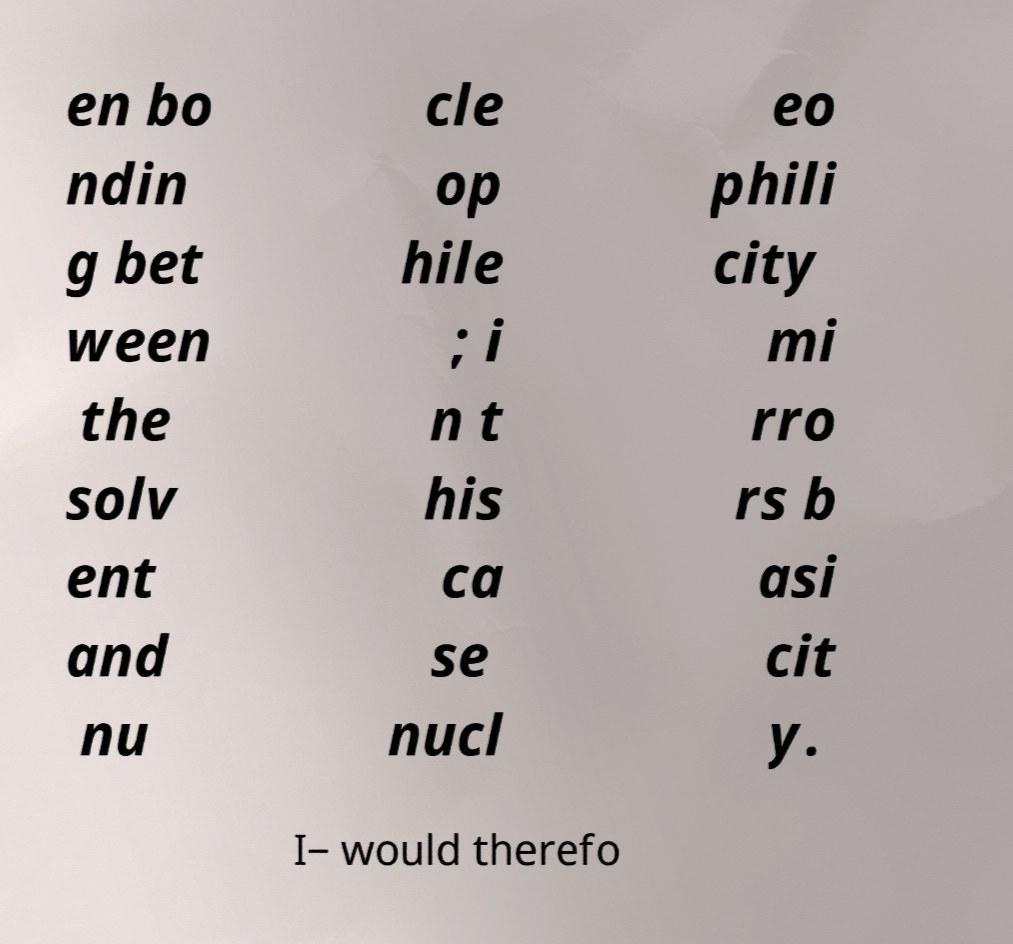Can you read and provide the text displayed in the image?This photo seems to have some interesting text. Can you extract and type it out for me? en bo ndin g bet ween the solv ent and nu cle op hile ; i n t his ca se nucl eo phili city mi rro rs b asi cit y. I− would therefo 